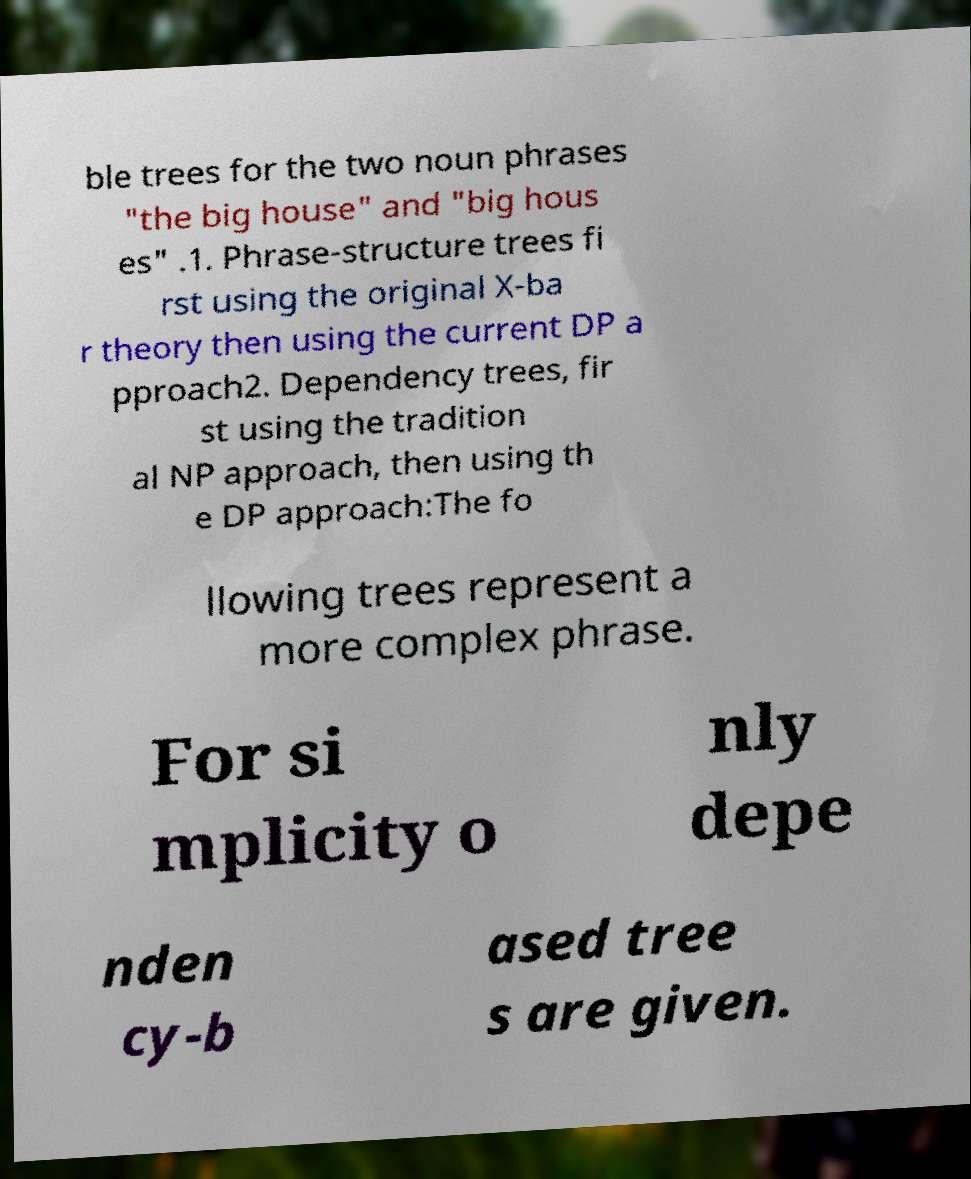Please read and relay the text visible in this image. What does it say? ble trees for the two noun phrases "the big house" and "big hous es" .1. Phrase-structure trees fi rst using the original X-ba r theory then using the current DP a pproach2. Dependency trees, fir st using the tradition al NP approach, then using th e DP approach:The fo llowing trees represent a more complex phrase. For si mplicity o nly depe nden cy-b ased tree s are given. 